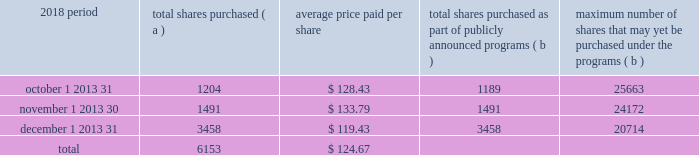The pnc financial services group , inc .
2013 form 10-k 29 part ii item 5 2013 market for registrant 2019s common equity , related stockholder matters and issuer purchases of equity securities ( a ) ( 1 ) our common stock is listed on the new york stock exchange and is traded under the symbol 201cpnc . 201d at the close of business on february 15 , 2019 , there were 53986 common shareholders of record .
Holders of pnc common stock are entitled to receive dividends when declared by our board of directors out of funds legally available for this purpose .
Our board of directors may not pay or set apart dividends on the common stock until dividends for all past dividend periods on any series of outstanding preferred stock and certain outstanding capital securities issued by the parent company have been paid or declared and set apart for payment .
The board of directors presently intends to continue the policy of paying quarterly cash dividends .
The amount of any future dividends will depend on economic and market conditions , our financial condition and operating results , and other factors , including contractual restrictions and applicable government regulations and policies ( such as those relating to the ability of bank and non-bank subsidiaries to pay dividends to the parent company and regulatory capital limitations ) .
The amount of our dividend is also currently subject to the results of the supervisory assessment of capital adequacy and capital planning processes undertaken by the federal reserve and our primary bank regulators as part of the comprehensive capital analysis and review ( ccar ) process as described in the supervision and regulation section in item 1 of this report .
The federal reserve has the power to prohibit us from paying dividends without its approval .
For further information concerning dividend restrictions and other factors that could limit our ability to pay dividends , as well as restrictions on loans , dividends or advances from bank subsidiaries to the parent company , see the supervision and regulation section in item 1 , item 1a risk factors , the liquidity and capital management portion of the risk management section in item 7 , and note 10 borrowed funds , note 15 equity and note 18 regulatory matters in the notes to consolidated financial statements in item 8 of this report , which we include here by reference .
We include here by reference the information regarding our compensation plans under which pnc equity securities are authorized for issuance as of december 31 , 2018 in the table ( with introductory paragraph and notes ) in item 12 of this report .
Our stock transfer agent and registrar is : computershare trust company , n.a .
250 royall street canton , ma 02021 800-982-7652 www.computershare.com/pnc registered shareholders may contact computershare regarding dividends and other shareholder services .
We include here by reference the information that appears under the common stock performance graph caption at the end of this item 5 .
( a ) ( 2 ) none .
( b ) not applicable .
( c ) details of our repurchases of pnc common stock during the fourth quarter of 2018 are included in the table : in thousands , except per share data 2018 period total shares purchased ( a ) average price paid per share total shares purchased as part of publicly announced programs ( b ) maximum number of shares that may yet be purchased under the programs ( b ) .
( a ) includes pnc common stock purchased in connection with our various employee benefit plans generally related to forfeitures of unvested restricted stock awards and shares used to cover employee payroll tax withholding requirements .
Note 11 employee benefit plans and note 12 stock based compensation plans in the notes to consolidated financial statements in item 8 of this report include additional information regarding our employee benefit and equity compensation plans that use pnc common stock .
( b ) on march 11 , 2015 , we announced that our board of directors approved a stock repurchase program authorization in the amount of 100 million shares of pnc common stock , effective april 1 , 2015 .
Repurchases are made in open market or privately negotiated transactions and the timing and exact amount of common stock repurchases will depend on a number of factors including , among others , market and general economic conditions , regulatory capital considerations , alternative uses of capital , the potential impact on our credit ratings , and contractual and regulatory limitations , including the results of the supervisory assessment of capital adequacy and capital planning processes undertaken by the federal reserve as part of the ccar process .
In june 2018 , we announced share repurchase programs of up to $ 2.0 billion for the four quarter period beginning with the third quarter of 2018 , including repurchases of up to $ 300 million related to stock issuances under employee benefit plans , in accordance with pnc's 2018 capital plan .
In november 2018 , we announced an increase to these previously announced programs in the amount of up to $ 900 million in additional common share repurchases .
The aggregate repurchase price of shares repurchased during the fourth quarter of 2018 was $ .8 billion .
See the liquidity and capital management portion of the risk management section in item 7 of this report for more information on the authorized share repurchase programs for the period july 1 , 2018 through june 30 , 2019 .
Http://www.computershare.com/pnc .
In the fourth quarter of 2018 what was the percent of the shares bought in december? 
Computations: (3458 / 6153)
Answer: 0.562. 